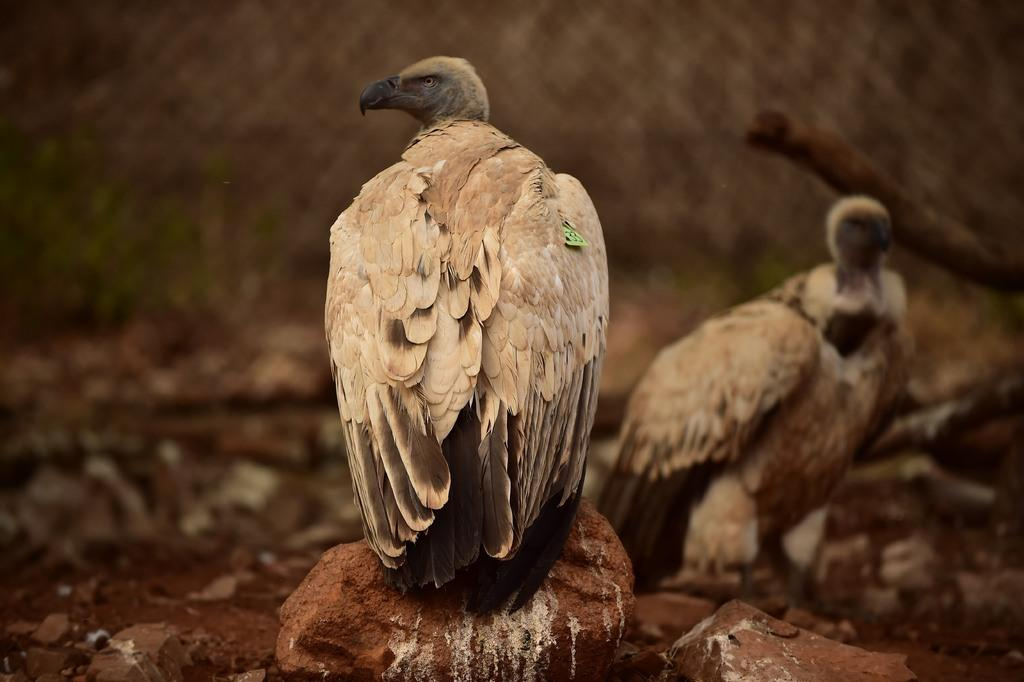What type of animals can be seen in the image? There are birds in the image. What other objects are present in the image? There are stones in the image. Can you describe the background of the image? The background of the image is blurred. How does the friend feel about the uncle's comfort in the image? There is no friend or uncle present in the image, so it is not possible to answer that question. 